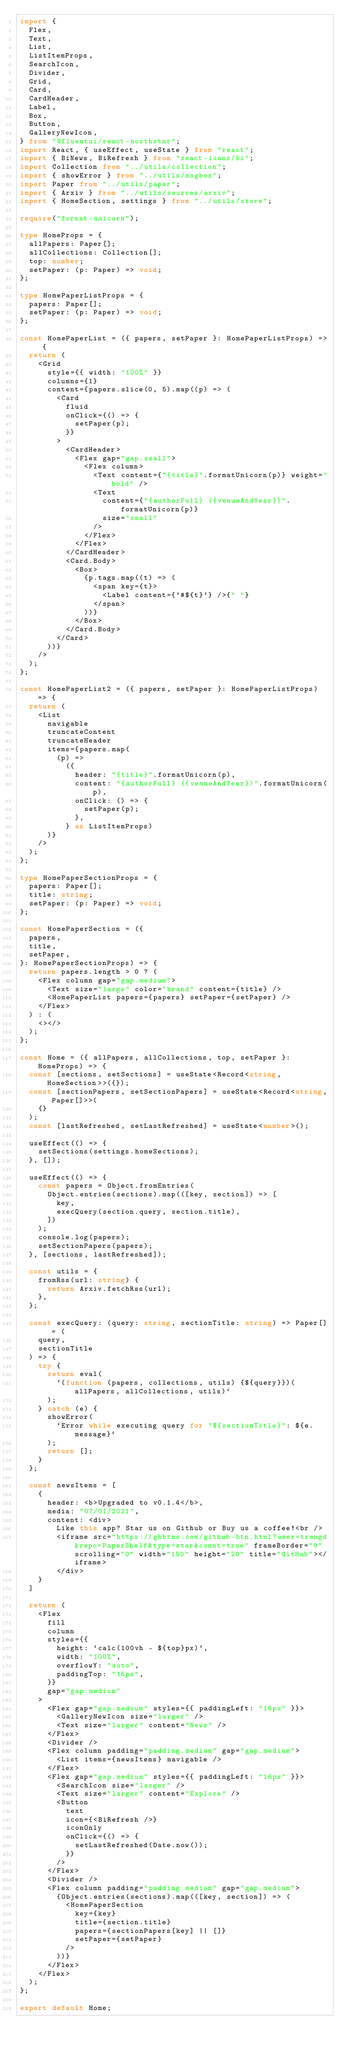<code> <loc_0><loc_0><loc_500><loc_500><_TypeScript_>import {
  Flex,
  Text,
  List,
  ListItemProps,
  SearchIcon,
  Divider,
  Grid,
  Card,
  CardHeader,
  Label,
  Box,
  Button,
  GalleryNewIcon,
} from "@fluentui/react-northstar";
import React, { useEffect, useState } from "react";
import { BiNews, BiRefresh } from "react-icons/bi";
import Collection from "../utils/collection";
import { showError } from "../utils/msgbox";
import Paper from "../utils/paper";
import { Arxiv } from "../utils/sources/arxiv";
import { HomeSection, settings } from "../utils/store";

require("format-unicorn");

type HomeProps = {
  allPapers: Paper[];
  allCollections: Collection[];
  top: number;
  setPaper: (p: Paper) => void;
};

type HomePaperListProps = {
  papers: Paper[];
  setPaper: (p: Paper) => void;
};

const HomePaperList = ({ papers, setPaper }: HomePaperListProps) => {
  return (
    <Grid
      style={{ width: "100%" }}
      columns={1}
      content={papers.slice(0, 5).map((p) => (
        <Card
          fluid
          onClick={() => {
            setPaper(p);
          }}
        >
          <CardHeader>
            <Flex gap="gap.small">
              <Flex column>
                <Text content={"{title}".formatUnicorn(p)} weight="bold" />
                <Text
                  content={"{authorFull} ({venueAndYear})".formatUnicorn(p)}
                  size="small"
                />
              </Flex>
            </Flex>
          </CardHeader>
          <Card.Body>
            <Box>
              {p.tags.map((t) => (
                <span key={t}>
                  <Label content={`#${t}`} />{" "}
                </span>
              ))}
            </Box>
          </Card.Body>
        </Card>
      ))}
    />
  );
};

const HomePaperList2 = ({ papers, setPaper }: HomePaperListProps) => {
  return (
    <List
      navigable
      truncateContent
      truncateHeader
      items={papers.map(
        (p) =>
          ({
            header: "{title}".formatUnicorn(p),
            content: "{authorFull} ({venueAndYear})".formatUnicorn(p),
            onClick: () => {
              setPaper(p);
            },
          } as ListItemProps)
      )}
    />
  );
};

type HomePaperSectionProps = {
  papers: Paper[];
  title: string;
  setPaper: (p: Paper) => void;
};

const HomePaperSection = ({
  papers,
  title,
  setPaper,
}: HomePaperSectionProps) => {
  return papers.length > 0 ? (
    <Flex column gap="gap.medium">
      <Text size="large" color="brand" content={title} />
      <HomePaperList papers={papers} setPaper={setPaper} />
    </Flex>
  ) : (
    <></>
  );
};

const Home = ({ allPapers, allCollections, top, setPaper }: HomeProps) => {
  const [sections, setSections] = useState<Record<string, HomeSection>>({});
  const [sectionPapers, setSectionPapers] = useState<Record<string, Paper[]>>(
    {}
  );
  const [lastRefreshed, setLastRefreshed] = useState<number>();

  useEffect(() => {
    setSections(settings.homeSections);
  }, []);

  useEffect(() => {
    const papers = Object.fromEntries(
      Object.entries(sections).map(([key, section]) => [
        key,
        execQuery(section.query, section.title),
      ])
    );
    console.log(papers);
    setSectionPapers(papers);
  }, [sections, lastRefreshed]);

  const utils = {
    fromRss(url: string) {
      return Arxiv.fetchRss(url);
    },
  };

  const execQuery: (query: string, sectionTitle: string) => Paper[] = (
    query,
    sectionTitle
  ) => {
    try {
      return eval(
        `(function (papers, collections, utils) {${query}})(allPapers, allCollections, utils)`
      );
    } catch (e) {
      showError(
        `Error while executing query for "${sectionTitle}": ${e.message}`
      );
      return [];
    }
  };

  const newsItems = [
    {
      header: <b>Upgraded to v0.1.4</b>,
      media: "07/01/2021",
      content: <div>
        Like this app? Star us on Github or Buy us a coffee!<br />
        <iframe src="https://ghbtns.com/github-btn.html?user=trungd&repo=PaperShelf&type=star&count=true" frameBorder="0" scrolling="0" width="150" height="20" title="GitHub"></iframe>
        </div>
    }
  ]

  return (
    <Flex
      fill
      column
      styles={{
        height: `calc(100vh - ${top}px)`,
        width: "100%",
        overflowY: "auto",
        paddingTop: "16px",
      }}
      gap="gap.medium"
    >
      <Flex gap="gap.medium" styles={{ paddingLeft: "16px" }}>
        <GalleryNewIcon size="larger" />
        <Text size="larger" content="News" />
      </Flex>
      <Divider />
      <Flex column padding="padding.medium" gap="gap.medium">
        <List items={newsItems} navigable />
      </Flex>
      <Flex gap="gap.medium" styles={{ paddingLeft: "16px" }}>
        <SearchIcon size="larger" />
        <Text size="larger" content="Explore" />
        <Button
          text
          icon={<BiRefresh />}
          iconOnly
          onClick={() => {
            setLastRefreshed(Date.now());
          }}
        />
      </Flex>
      <Divider />
      <Flex column padding="padding.medium" gap="gap.medium">
        {Object.entries(sections).map(([key, section]) => (
          <HomePaperSection
            key={key}
            title={section.title}
            papers={sectionPapers[key] || []}
            setPaper={setPaper}
          />
        ))}
      </Flex>
    </Flex>
  );
};

export default Home;
</code> 